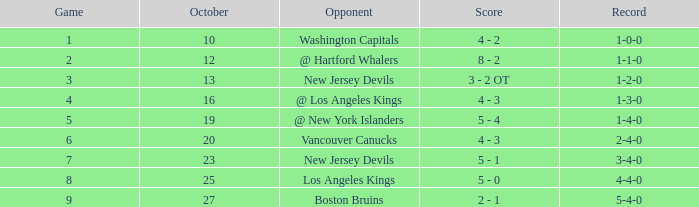In a game with a 4-4-0 record, what was the typical result? 8.0. 